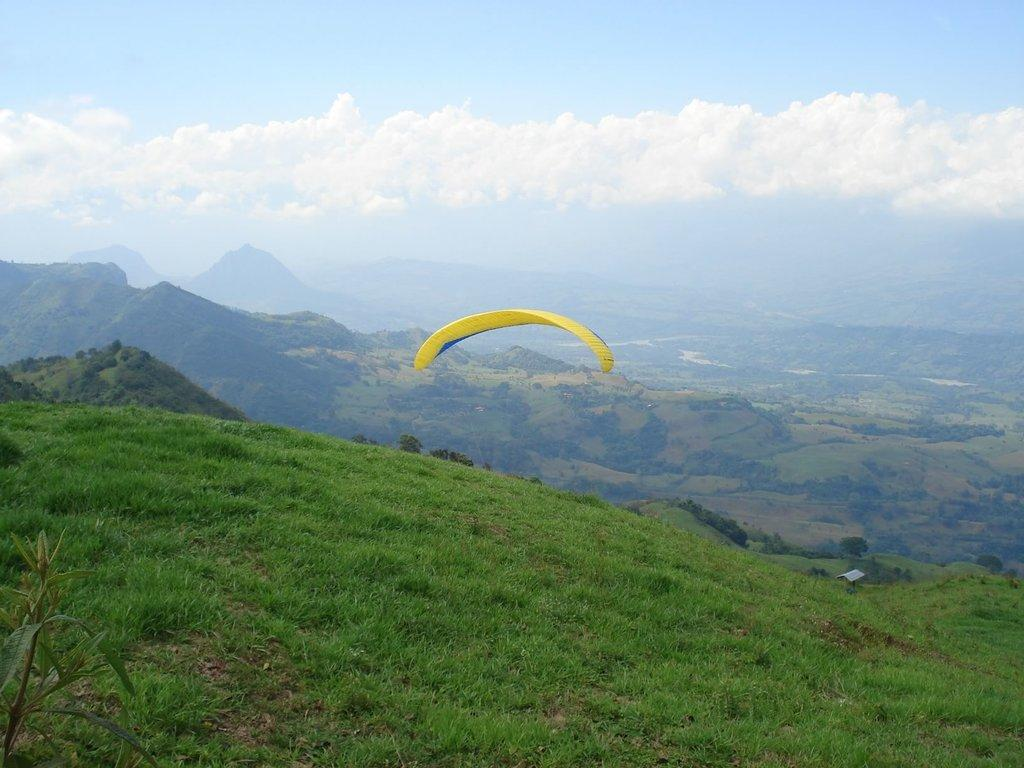What is the main object in the image? There is a parachute in the image. What other objects can be seen in the image? There is a plant, grass, a house with a roof, and trees in the image. What is visible in the background of the image? Mountains are visible in the background of the image. How would you describe the sky in the image? The sky is visible in the image and appears cloudy. What type of instrument is being played by the plant in the image? There is no instrument being played by the plant in the image, as plants do not have the ability to play instruments. 